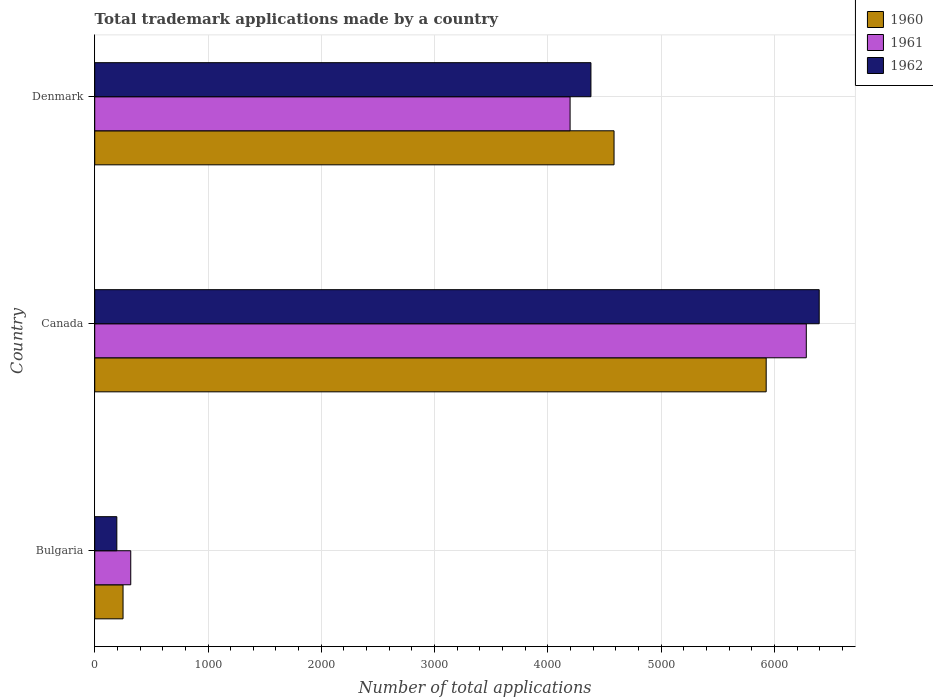How many groups of bars are there?
Ensure brevity in your answer.  3. Are the number of bars per tick equal to the number of legend labels?
Provide a succinct answer. Yes. Are the number of bars on each tick of the Y-axis equal?
Offer a terse response. Yes. What is the label of the 1st group of bars from the top?
Your answer should be very brief. Denmark. What is the number of applications made by in 1960 in Canada?
Keep it short and to the point. 5927. Across all countries, what is the maximum number of applications made by in 1962?
Your response must be concise. 6395. Across all countries, what is the minimum number of applications made by in 1960?
Ensure brevity in your answer.  250. In which country was the number of applications made by in 1960 maximum?
Make the answer very short. Canada. In which country was the number of applications made by in 1961 minimum?
Your response must be concise. Bulgaria. What is the total number of applications made by in 1962 in the graph?
Your answer should be compact. 1.10e+04. What is the difference between the number of applications made by in 1962 in Canada and that in Denmark?
Keep it short and to the point. 2015. What is the difference between the number of applications made by in 1962 in Denmark and the number of applications made by in 1961 in Bulgaria?
Keep it short and to the point. 4062. What is the average number of applications made by in 1961 per country?
Ensure brevity in your answer.  3598.33. What is the difference between the number of applications made by in 1962 and number of applications made by in 1960 in Denmark?
Provide a short and direct response. -204. What is the ratio of the number of applications made by in 1962 in Bulgaria to that in Canada?
Give a very brief answer. 0.03. Is the number of applications made by in 1962 in Canada less than that in Denmark?
Your response must be concise. No. What is the difference between the highest and the second highest number of applications made by in 1962?
Provide a succinct answer. 2015. What is the difference between the highest and the lowest number of applications made by in 1961?
Provide a succinct answer. 5963. What does the 2nd bar from the top in Denmark represents?
Provide a short and direct response. 1961. What does the 2nd bar from the bottom in Denmark represents?
Provide a succinct answer. 1961. Does the graph contain any zero values?
Provide a short and direct response. No. How are the legend labels stacked?
Offer a very short reply. Vertical. What is the title of the graph?
Provide a succinct answer. Total trademark applications made by a country. Does "2004" appear as one of the legend labels in the graph?
Your answer should be compact. No. What is the label or title of the X-axis?
Your response must be concise. Number of total applications. What is the label or title of the Y-axis?
Offer a very short reply. Country. What is the Number of total applications in 1960 in Bulgaria?
Offer a very short reply. 250. What is the Number of total applications in 1961 in Bulgaria?
Give a very brief answer. 318. What is the Number of total applications of 1962 in Bulgaria?
Offer a terse response. 195. What is the Number of total applications in 1960 in Canada?
Your response must be concise. 5927. What is the Number of total applications in 1961 in Canada?
Offer a terse response. 6281. What is the Number of total applications of 1962 in Canada?
Offer a terse response. 6395. What is the Number of total applications in 1960 in Denmark?
Your response must be concise. 4584. What is the Number of total applications in 1961 in Denmark?
Provide a short and direct response. 4196. What is the Number of total applications of 1962 in Denmark?
Give a very brief answer. 4380. Across all countries, what is the maximum Number of total applications of 1960?
Offer a terse response. 5927. Across all countries, what is the maximum Number of total applications of 1961?
Ensure brevity in your answer.  6281. Across all countries, what is the maximum Number of total applications in 1962?
Offer a very short reply. 6395. Across all countries, what is the minimum Number of total applications of 1960?
Your answer should be compact. 250. Across all countries, what is the minimum Number of total applications of 1961?
Your answer should be compact. 318. Across all countries, what is the minimum Number of total applications of 1962?
Your answer should be compact. 195. What is the total Number of total applications in 1960 in the graph?
Make the answer very short. 1.08e+04. What is the total Number of total applications in 1961 in the graph?
Offer a terse response. 1.08e+04. What is the total Number of total applications in 1962 in the graph?
Keep it short and to the point. 1.10e+04. What is the difference between the Number of total applications in 1960 in Bulgaria and that in Canada?
Provide a succinct answer. -5677. What is the difference between the Number of total applications in 1961 in Bulgaria and that in Canada?
Offer a terse response. -5963. What is the difference between the Number of total applications in 1962 in Bulgaria and that in Canada?
Keep it short and to the point. -6200. What is the difference between the Number of total applications of 1960 in Bulgaria and that in Denmark?
Offer a very short reply. -4334. What is the difference between the Number of total applications of 1961 in Bulgaria and that in Denmark?
Your answer should be very brief. -3878. What is the difference between the Number of total applications of 1962 in Bulgaria and that in Denmark?
Your response must be concise. -4185. What is the difference between the Number of total applications of 1960 in Canada and that in Denmark?
Give a very brief answer. 1343. What is the difference between the Number of total applications of 1961 in Canada and that in Denmark?
Give a very brief answer. 2085. What is the difference between the Number of total applications in 1962 in Canada and that in Denmark?
Ensure brevity in your answer.  2015. What is the difference between the Number of total applications in 1960 in Bulgaria and the Number of total applications in 1961 in Canada?
Provide a short and direct response. -6031. What is the difference between the Number of total applications of 1960 in Bulgaria and the Number of total applications of 1962 in Canada?
Offer a very short reply. -6145. What is the difference between the Number of total applications of 1961 in Bulgaria and the Number of total applications of 1962 in Canada?
Keep it short and to the point. -6077. What is the difference between the Number of total applications of 1960 in Bulgaria and the Number of total applications of 1961 in Denmark?
Provide a succinct answer. -3946. What is the difference between the Number of total applications of 1960 in Bulgaria and the Number of total applications of 1962 in Denmark?
Ensure brevity in your answer.  -4130. What is the difference between the Number of total applications of 1961 in Bulgaria and the Number of total applications of 1962 in Denmark?
Ensure brevity in your answer.  -4062. What is the difference between the Number of total applications of 1960 in Canada and the Number of total applications of 1961 in Denmark?
Your answer should be compact. 1731. What is the difference between the Number of total applications of 1960 in Canada and the Number of total applications of 1962 in Denmark?
Your answer should be compact. 1547. What is the difference between the Number of total applications in 1961 in Canada and the Number of total applications in 1962 in Denmark?
Give a very brief answer. 1901. What is the average Number of total applications in 1960 per country?
Ensure brevity in your answer.  3587. What is the average Number of total applications of 1961 per country?
Provide a short and direct response. 3598.33. What is the average Number of total applications in 1962 per country?
Make the answer very short. 3656.67. What is the difference between the Number of total applications of 1960 and Number of total applications of 1961 in Bulgaria?
Ensure brevity in your answer.  -68. What is the difference between the Number of total applications in 1960 and Number of total applications in 1962 in Bulgaria?
Provide a short and direct response. 55. What is the difference between the Number of total applications of 1961 and Number of total applications of 1962 in Bulgaria?
Make the answer very short. 123. What is the difference between the Number of total applications of 1960 and Number of total applications of 1961 in Canada?
Provide a short and direct response. -354. What is the difference between the Number of total applications of 1960 and Number of total applications of 1962 in Canada?
Offer a very short reply. -468. What is the difference between the Number of total applications of 1961 and Number of total applications of 1962 in Canada?
Provide a short and direct response. -114. What is the difference between the Number of total applications in 1960 and Number of total applications in 1961 in Denmark?
Offer a terse response. 388. What is the difference between the Number of total applications in 1960 and Number of total applications in 1962 in Denmark?
Your answer should be very brief. 204. What is the difference between the Number of total applications in 1961 and Number of total applications in 1962 in Denmark?
Provide a short and direct response. -184. What is the ratio of the Number of total applications of 1960 in Bulgaria to that in Canada?
Keep it short and to the point. 0.04. What is the ratio of the Number of total applications of 1961 in Bulgaria to that in Canada?
Keep it short and to the point. 0.05. What is the ratio of the Number of total applications in 1962 in Bulgaria to that in Canada?
Provide a short and direct response. 0.03. What is the ratio of the Number of total applications of 1960 in Bulgaria to that in Denmark?
Your response must be concise. 0.05. What is the ratio of the Number of total applications of 1961 in Bulgaria to that in Denmark?
Ensure brevity in your answer.  0.08. What is the ratio of the Number of total applications of 1962 in Bulgaria to that in Denmark?
Your answer should be compact. 0.04. What is the ratio of the Number of total applications in 1960 in Canada to that in Denmark?
Provide a short and direct response. 1.29. What is the ratio of the Number of total applications of 1961 in Canada to that in Denmark?
Ensure brevity in your answer.  1.5. What is the ratio of the Number of total applications in 1962 in Canada to that in Denmark?
Your response must be concise. 1.46. What is the difference between the highest and the second highest Number of total applications in 1960?
Provide a succinct answer. 1343. What is the difference between the highest and the second highest Number of total applications in 1961?
Your answer should be compact. 2085. What is the difference between the highest and the second highest Number of total applications in 1962?
Your response must be concise. 2015. What is the difference between the highest and the lowest Number of total applications in 1960?
Your answer should be very brief. 5677. What is the difference between the highest and the lowest Number of total applications in 1961?
Your response must be concise. 5963. What is the difference between the highest and the lowest Number of total applications of 1962?
Keep it short and to the point. 6200. 